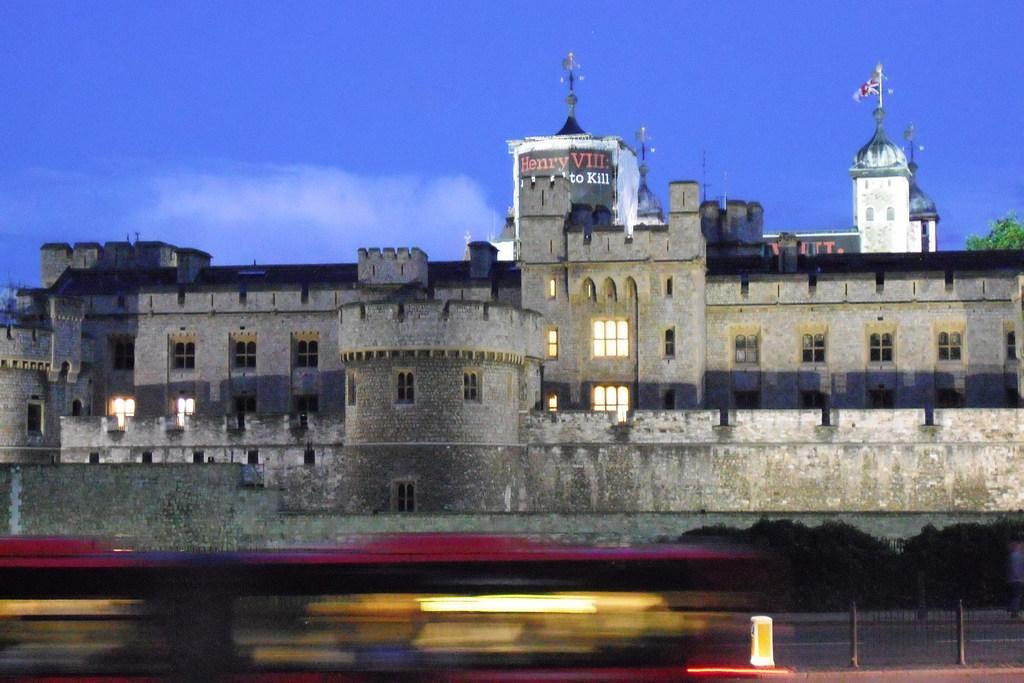In one or two sentences, can you explain what this image depicts? In this image at the bottom we can see the image is blur but we can see an object, fence and road. In the background there are trees, buildings, windows, a tree on the right side and clouds in the sky. 